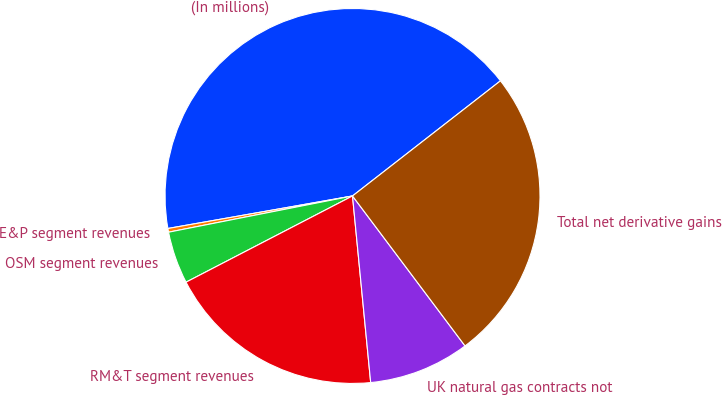Convert chart. <chart><loc_0><loc_0><loc_500><loc_500><pie_chart><fcel>(In millions)<fcel>E&P segment revenues<fcel>OSM segment revenues<fcel>RM&T segment revenues<fcel>UK natural gas contracts not<fcel>Total net derivative gains<nl><fcel>42.25%<fcel>0.32%<fcel>4.51%<fcel>18.94%<fcel>8.7%<fcel>25.28%<nl></chart> 